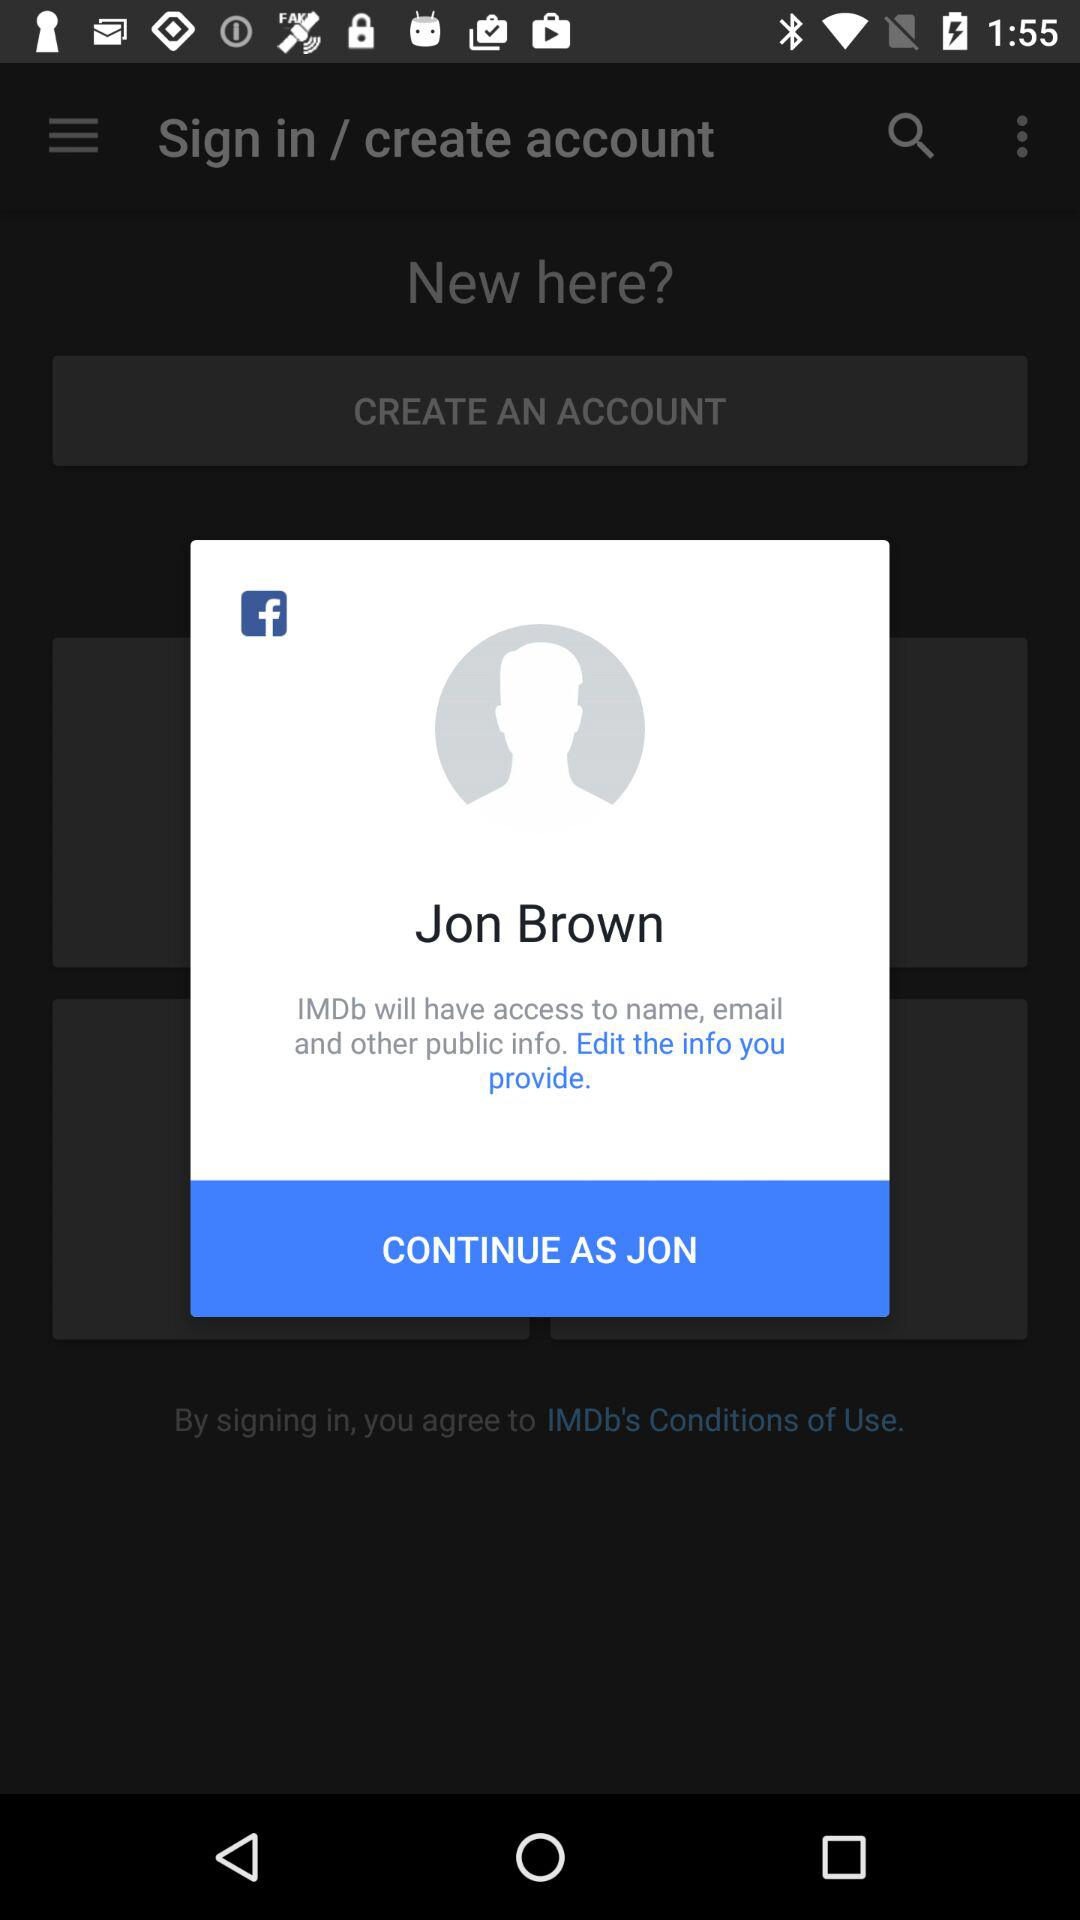What is the user name? The user name is Jon Brown. 